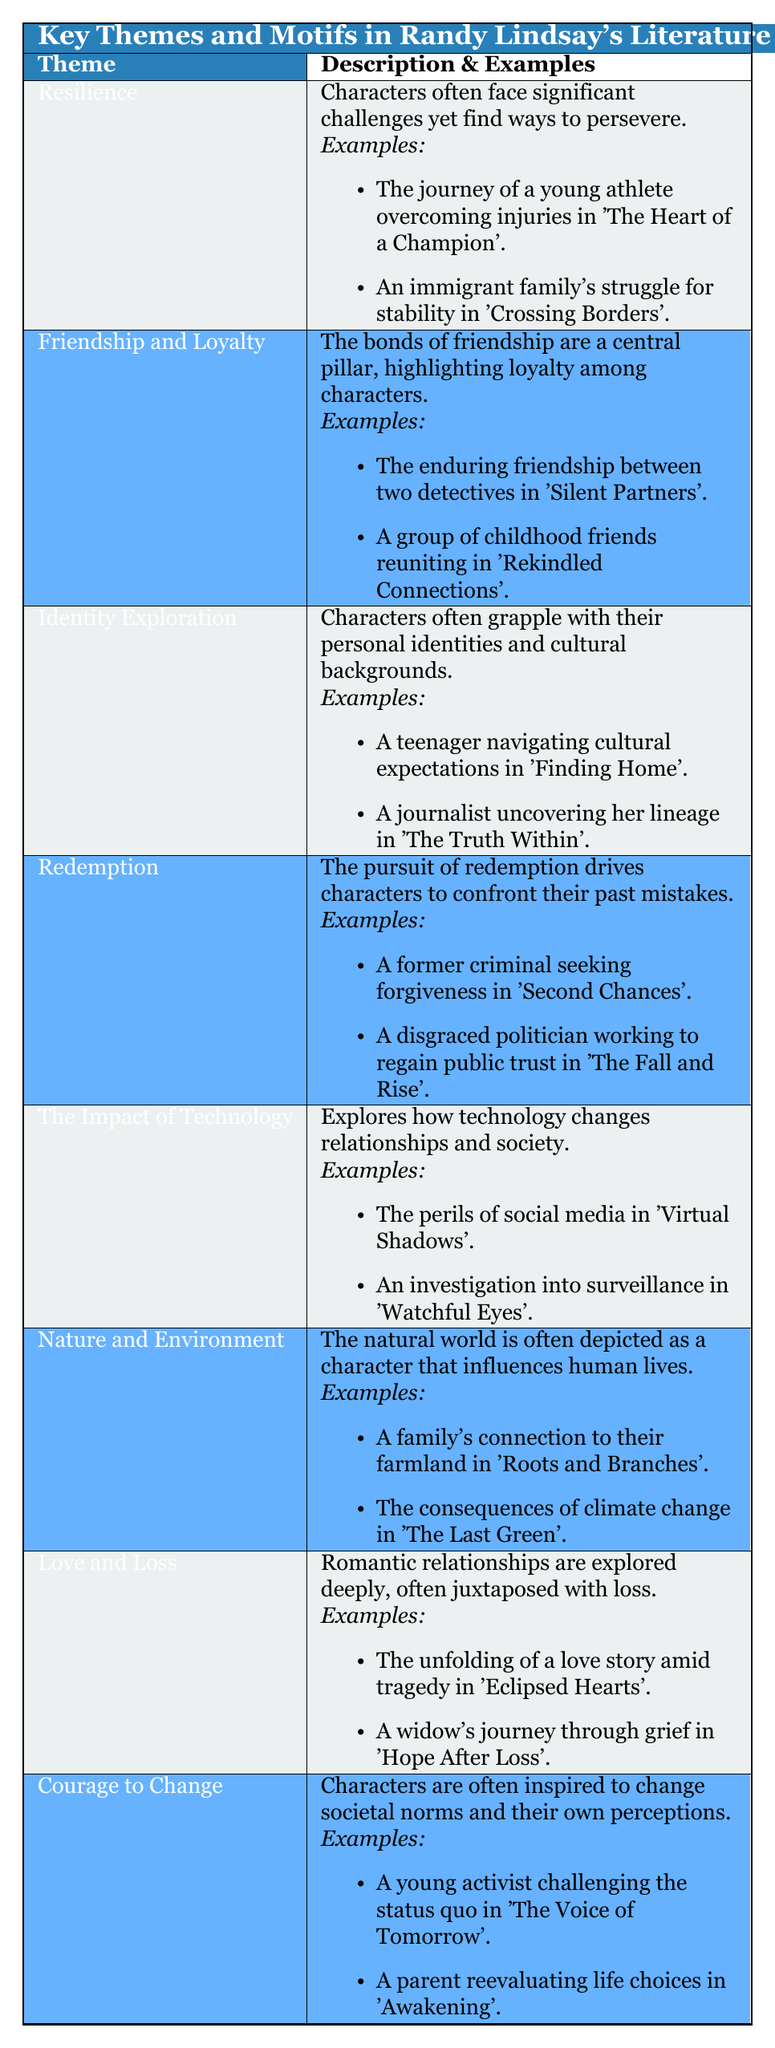What theme is depicted through a young athlete's journey in 'The Heart of a Champion'? The theme depicted is "Resilience," as it showcases the character overcoming significant challenges.
Answer: Resilience How many examples are provided for the theme of 'Love and Loss'? There are two examples given for the theme of 'Love and Loss': "The unfolding of a love story amid tragedy in 'Eclipsed Hearts'" and "A widow's journey through grief in 'Hope After Loss'."
Answer: Two True or False: 'Identity Exploration' includes a character's journey through grief in its examples. False, because 'Identity Exploration' features examples of navigating cultural expectations and uncovering lineage, not dealing with grief.
Answer: False Which themes contain elements related to societal perceptions and norms? The themes that involve societal perceptions and norms are "Courage to Change," which explicitly mentions changing societal norms, and "The Impact of Technology," reflecting on how technology alters relationships in society.
Answer: Courage to Change, The Impact of Technology If you sum the number of examples for 'Redemption' and 'Nature and Environment', what is the total? Each theme contains two examples, so when summed (2 examples for Redemption + 2 examples for Nature and Environment = 4), the total is 4.
Answer: 4 What characterizes the portrayal of nature in Randy Lindsay's literature? The character of nature is depicted as a powerful influence on human lives, as shown through examples like a family's connection to farmland and the consequences of climate change.
Answer: Nature influences human lives How might the theme of 'Friendship and Loyalty' be seen in 'Silent Partners'? This theme is illustrated through the enduring friendship between two detectives, demonstrating loyalty amidst challenges.
Answer: Enduring friendship between detectives What is one example that illustrates the theme of 'Courage to Change'? One example is "A young activist challenging the status quo in 'The Voice of Tomorrow'," showing a character inspired to bring change.
Answer: A young activist in 'The Voice of Tomorrow' 